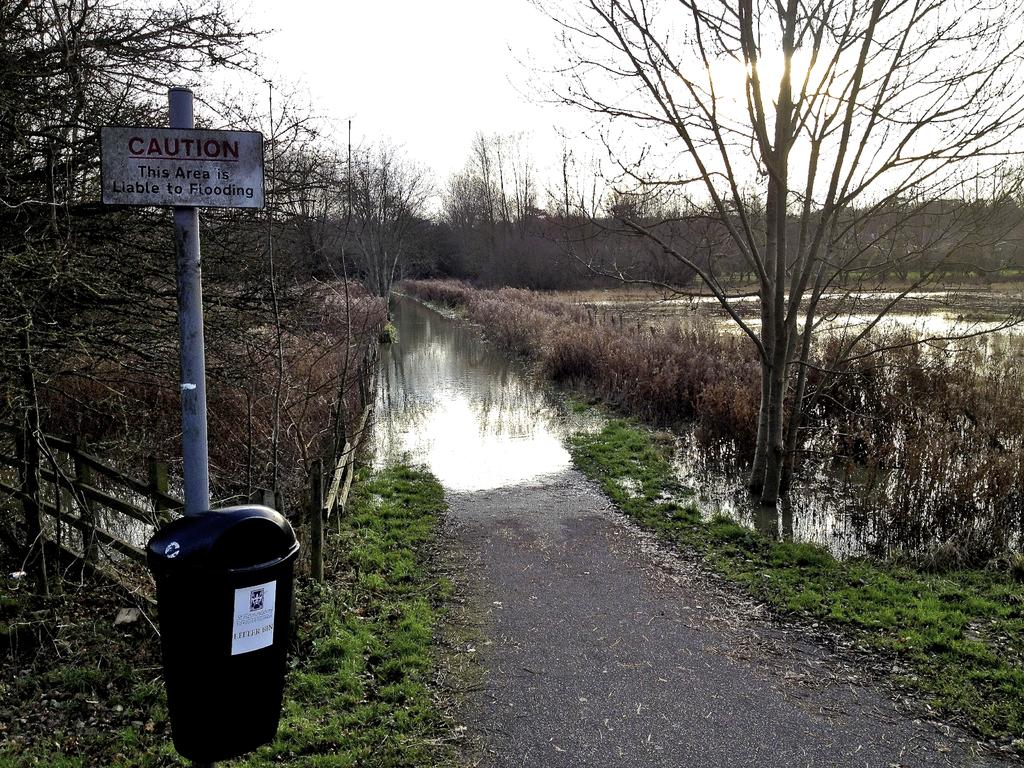What is this area liable to?
Your answer should be very brief. Flooding. 